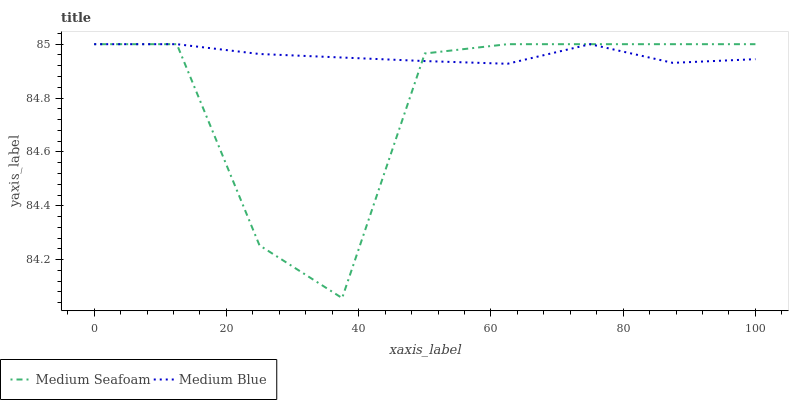Does Medium Seafoam have the minimum area under the curve?
Answer yes or no. Yes. Does Medium Blue have the maximum area under the curve?
Answer yes or no. Yes. Does Medium Seafoam have the maximum area under the curve?
Answer yes or no. No. Is Medium Blue the smoothest?
Answer yes or no. Yes. Is Medium Seafoam the roughest?
Answer yes or no. Yes. Is Medium Seafoam the smoothest?
Answer yes or no. No. Does Medium Seafoam have the lowest value?
Answer yes or no. Yes. Does Medium Seafoam have the highest value?
Answer yes or no. Yes. Does Medium Blue intersect Medium Seafoam?
Answer yes or no. Yes. Is Medium Blue less than Medium Seafoam?
Answer yes or no. No. Is Medium Blue greater than Medium Seafoam?
Answer yes or no. No. 